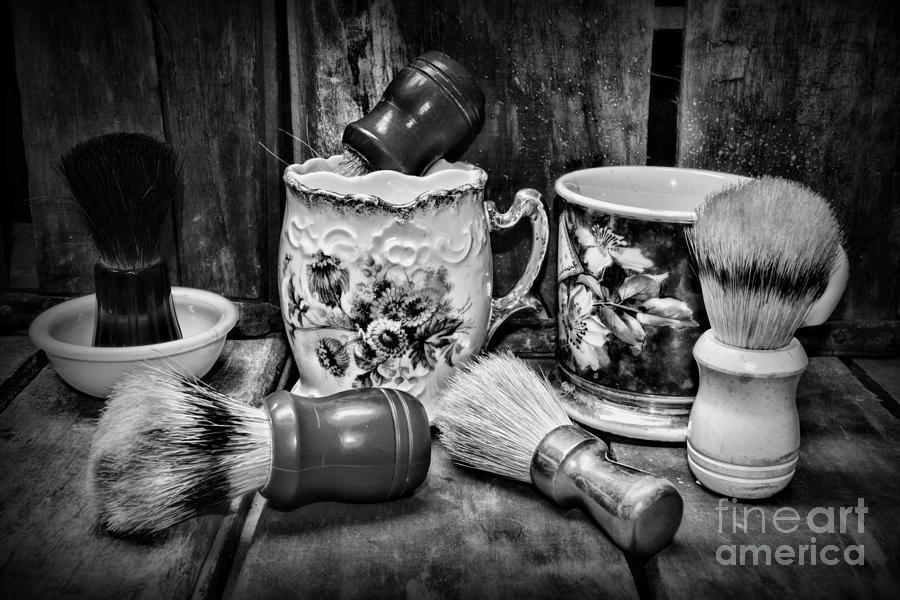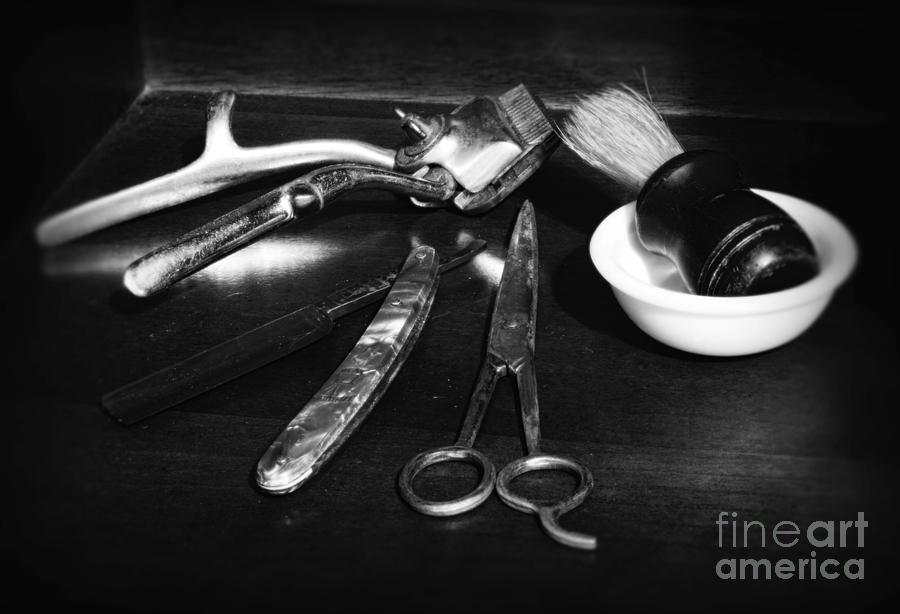The first image is the image on the left, the second image is the image on the right. For the images shown, is this caption "An image shows a display of barber tools, including scissors." true? Answer yes or no. Yes. The first image is the image on the left, the second image is the image on the right. For the images displayed, is the sentence "A barbershop image shows a man sitting in a barber chair with other people in the shop, and large windows in the background." factually correct? Answer yes or no. No. 